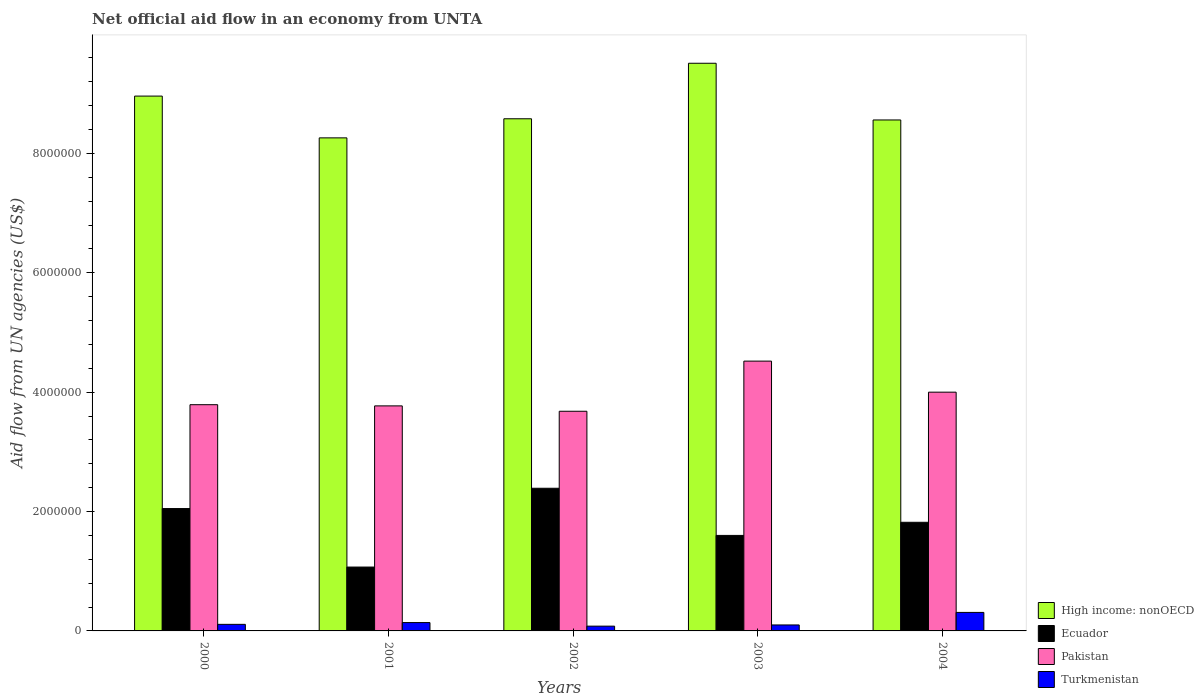How many different coloured bars are there?
Provide a succinct answer. 4. How many groups of bars are there?
Provide a short and direct response. 5. What is the label of the 1st group of bars from the left?
Offer a terse response. 2000. What is the net official aid flow in Turkmenistan in 2001?
Ensure brevity in your answer.  1.40e+05. Across all years, what is the maximum net official aid flow in High income: nonOECD?
Your answer should be compact. 9.51e+06. Across all years, what is the minimum net official aid flow in Pakistan?
Provide a short and direct response. 3.68e+06. In which year was the net official aid flow in Turkmenistan maximum?
Ensure brevity in your answer.  2004. In which year was the net official aid flow in High income: nonOECD minimum?
Give a very brief answer. 2001. What is the total net official aid flow in High income: nonOECD in the graph?
Your response must be concise. 4.39e+07. What is the difference between the net official aid flow in Ecuador in 2001 and that in 2002?
Make the answer very short. -1.32e+06. What is the difference between the net official aid flow in Turkmenistan in 2003 and the net official aid flow in Ecuador in 2001?
Make the answer very short. -9.70e+05. What is the average net official aid flow in Ecuador per year?
Ensure brevity in your answer.  1.79e+06. In the year 2002, what is the difference between the net official aid flow in High income: nonOECD and net official aid flow in Pakistan?
Keep it short and to the point. 4.90e+06. What is the ratio of the net official aid flow in Ecuador in 2003 to that in 2004?
Give a very brief answer. 0.88. Is the difference between the net official aid flow in High income: nonOECD in 2000 and 2001 greater than the difference between the net official aid flow in Pakistan in 2000 and 2001?
Give a very brief answer. Yes. In how many years, is the net official aid flow in High income: nonOECD greater than the average net official aid flow in High income: nonOECD taken over all years?
Your answer should be very brief. 2. Is the sum of the net official aid flow in Turkmenistan in 2001 and 2002 greater than the maximum net official aid flow in Ecuador across all years?
Provide a short and direct response. No. What does the 4th bar from the left in 2002 represents?
Ensure brevity in your answer.  Turkmenistan. Is it the case that in every year, the sum of the net official aid flow in Pakistan and net official aid flow in Ecuador is greater than the net official aid flow in High income: nonOECD?
Make the answer very short. No. How many years are there in the graph?
Ensure brevity in your answer.  5. Does the graph contain any zero values?
Your answer should be very brief. No. Where does the legend appear in the graph?
Your answer should be compact. Bottom right. How many legend labels are there?
Your response must be concise. 4. How are the legend labels stacked?
Offer a terse response. Vertical. What is the title of the graph?
Provide a succinct answer. Net official aid flow in an economy from UNTA. What is the label or title of the X-axis?
Provide a short and direct response. Years. What is the label or title of the Y-axis?
Your answer should be very brief. Aid flow from UN agencies (US$). What is the Aid flow from UN agencies (US$) in High income: nonOECD in 2000?
Keep it short and to the point. 8.96e+06. What is the Aid flow from UN agencies (US$) in Ecuador in 2000?
Your answer should be compact. 2.05e+06. What is the Aid flow from UN agencies (US$) in Pakistan in 2000?
Offer a terse response. 3.79e+06. What is the Aid flow from UN agencies (US$) in High income: nonOECD in 2001?
Ensure brevity in your answer.  8.26e+06. What is the Aid flow from UN agencies (US$) of Ecuador in 2001?
Ensure brevity in your answer.  1.07e+06. What is the Aid flow from UN agencies (US$) in Pakistan in 2001?
Make the answer very short. 3.77e+06. What is the Aid flow from UN agencies (US$) of High income: nonOECD in 2002?
Offer a terse response. 8.58e+06. What is the Aid flow from UN agencies (US$) of Ecuador in 2002?
Offer a terse response. 2.39e+06. What is the Aid flow from UN agencies (US$) in Pakistan in 2002?
Provide a succinct answer. 3.68e+06. What is the Aid flow from UN agencies (US$) of High income: nonOECD in 2003?
Provide a succinct answer. 9.51e+06. What is the Aid flow from UN agencies (US$) of Ecuador in 2003?
Your answer should be compact. 1.60e+06. What is the Aid flow from UN agencies (US$) in Pakistan in 2003?
Offer a terse response. 4.52e+06. What is the Aid flow from UN agencies (US$) in High income: nonOECD in 2004?
Your answer should be compact. 8.56e+06. What is the Aid flow from UN agencies (US$) in Ecuador in 2004?
Ensure brevity in your answer.  1.82e+06. What is the Aid flow from UN agencies (US$) in Pakistan in 2004?
Ensure brevity in your answer.  4.00e+06. Across all years, what is the maximum Aid flow from UN agencies (US$) of High income: nonOECD?
Give a very brief answer. 9.51e+06. Across all years, what is the maximum Aid flow from UN agencies (US$) in Ecuador?
Provide a succinct answer. 2.39e+06. Across all years, what is the maximum Aid flow from UN agencies (US$) of Pakistan?
Make the answer very short. 4.52e+06. Across all years, what is the maximum Aid flow from UN agencies (US$) in Turkmenistan?
Keep it short and to the point. 3.10e+05. Across all years, what is the minimum Aid flow from UN agencies (US$) of High income: nonOECD?
Offer a terse response. 8.26e+06. Across all years, what is the minimum Aid flow from UN agencies (US$) in Ecuador?
Offer a very short reply. 1.07e+06. Across all years, what is the minimum Aid flow from UN agencies (US$) in Pakistan?
Ensure brevity in your answer.  3.68e+06. What is the total Aid flow from UN agencies (US$) in High income: nonOECD in the graph?
Offer a very short reply. 4.39e+07. What is the total Aid flow from UN agencies (US$) in Ecuador in the graph?
Give a very brief answer. 8.93e+06. What is the total Aid flow from UN agencies (US$) in Pakistan in the graph?
Make the answer very short. 1.98e+07. What is the total Aid flow from UN agencies (US$) in Turkmenistan in the graph?
Your response must be concise. 7.40e+05. What is the difference between the Aid flow from UN agencies (US$) in High income: nonOECD in 2000 and that in 2001?
Give a very brief answer. 7.00e+05. What is the difference between the Aid flow from UN agencies (US$) of Ecuador in 2000 and that in 2001?
Offer a terse response. 9.80e+05. What is the difference between the Aid flow from UN agencies (US$) of Pakistan in 2000 and that in 2001?
Your answer should be compact. 2.00e+04. What is the difference between the Aid flow from UN agencies (US$) of Turkmenistan in 2000 and that in 2001?
Provide a succinct answer. -3.00e+04. What is the difference between the Aid flow from UN agencies (US$) of Pakistan in 2000 and that in 2002?
Provide a succinct answer. 1.10e+05. What is the difference between the Aid flow from UN agencies (US$) of Turkmenistan in 2000 and that in 2002?
Provide a succinct answer. 3.00e+04. What is the difference between the Aid flow from UN agencies (US$) of High income: nonOECD in 2000 and that in 2003?
Give a very brief answer. -5.50e+05. What is the difference between the Aid flow from UN agencies (US$) of Ecuador in 2000 and that in 2003?
Give a very brief answer. 4.50e+05. What is the difference between the Aid flow from UN agencies (US$) of Pakistan in 2000 and that in 2003?
Keep it short and to the point. -7.30e+05. What is the difference between the Aid flow from UN agencies (US$) in High income: nonOECD in 2000 and that in 2004?
Provide a short and direct response. 4.00e+05. What is the difference between the Aid flow from UN agencies (US$) in Ecuador in 2000 and that in 2004?
Provide a short and direct response. 2.30e+05. What is the difference between the Aid flow from UN agencies (US$) in Pakistan in 2000 and that in 2004?
Offer a terse response. -2.10e+05. What is the difference between the Aid flow from UN agencies (US$) in Turkmenistan in 2000 and that in 2004?
Provide a short and direct response. -2.00e+05. What is the difference between the Aid flow from UN agencies (US$) in High income: nonOECD in 2001 and that in 2002?
Make the answer very short. -3.20e+05. What is the difference between the Aid flow from UN agencies (US$) of Ecuador in 2001 and that in 2002?
Provide a short and direct response. -1.32e+06. What is the difference between the Aid flow from UN agencies (US$) in High income: nonOECD in 2001 and that in 2003?
Provide a short and direct response. -1.25e+06. What is the difference between the Aid flow from UN agencies (US$) of Ecuador in 2001 and that in 2003?
Keep it short and to the point. -5.30e+05. What is the difference between the Aid flow from UN agencies (US$) in Pakistan in 2001 and that in 2003?
Ensure brevity in your answer.  -7.50e+05. What is the difference between the Aid flow from UN agencies (US$) of High income: nonOECD in 2001 and that in 2004?
Your response must be concise. -3.00e+05. What is the difference between the Aid flow from UN agencies (US$) of Ecuador in 2001 and that in 2004?
Make the answer very short. -7.50e+05. What is the difference between the Aid flow from UN agencies (US$) of Pakistan in 2001 and that in 2004?
Give a very brief answer. -2.30e+05. What is the difference between the Aid flow from UN agencies (US$) of High income: nonOECD in 2002 and that in 2003?
Ensure brevity in your answer.  -9.30e+05. What is the difference between the Aid flow from UN agencies (US$) in Ecuador in 2002 and that in 2003?
Give a very brief answer. 7.90e+05. What is the difference between the Aid flow from UN agencies (US$) in Pakistan in 2002 and that in 2003?
Your answer should be very brief. -8.40e+05. What is the difference between the Aid flow from UN agencies (US$) of High income: nonOECD in 2002 and that in 2004?
Provide a succinct answer. 2.00e+04. What is the difference between the Aid flow from UN agencies (US$) in Ecuador in 2002 and that in 2004?
Make the answer very short. 5.70e+05. What is the difference between the Aid flow from UN agencies (US$) of Pakistan in 2002 and that in 2004?
Keep it short and to the point. -3.20e+05. What is the difference between the Aid flow from UN agencies (US$) in High income: nonOECD in 2003 and that in 2004?
Ensure brevity in your answer.  9.50e+05. What is the difference between the Aid flow from UN agencies (US$) of Pakistan in 2003 and that in 2004?
Offer a very short reply. 5.20e+05. What is the difference between the Aid flow from UN agencies (US$) of Turkmenistan in 2003 and that in 2004?
Your answer should be very brief. -2.10e+05. What is the difference between the Aid flow from UN agencies (US$) of High income: nonOECD in 2000 and the Aid flow from UN agencies (US$) of Ecuador in 2001?
Give a very brief answer. 7.89e+06. What is the difference between the Aid flow from UN agencies (US$) in High income: nonOECD in 2000 and the Aid flow from UN agencies (US$) in Pakistan in 2001?
Provide a short and direct response. 5.19e+06. What is the difference between the Aid flow from UN agencies (US$) of High income: nonOECD in 2000 and the Aid flow from UN agencies (US$) of Turkmenistan in 2001?
Your answer should be very brief. 8.82e+06. What is the difference between the Aid flow from UN agencies (US$) of Ecuador in 2000 and the Aid flow from UN agencies (US$) of Pakistan in 2001?
Your response must be concise. -1.72e+06. What is the difference between the Aid flow from UN agencies (US$) in Ecuador in 2000 and the Aid flow from UN agencies (US$) in Turkmenistan in 2001?
Your response must be concise. 1.91e+06. What is the difference between the Aid flow from UN agencies (US$) of Pakistan in 2000 and the Aid flow from UN agencies (US$) of Turkmenistan in 2001?
Offer a terse response. 3.65e+06. What is the difference between the Aid flow from UN agencies (US$) in High income: nonOECD in 2000 and the Aid flow from UN agencies (US$) in Ecuador in 2002?
Keep it short and to the point. 6.57e+06. What is the difference between the Aid flow from UN agencies (US$) of High income: nonOECD in 2000 and the Aid flow from UN agencies (US$) of Pakistan in 2002?
Offer a very short reply. 5.28e+06. What is the difference between the Aid flow from UN agencies (US$) of High income: nonOECD in 2000 and the Aid flow from UN agencies (US$) of Turkmenistan in 2002?
Give a very brief answer. 8.88e+06. What is the difference between the Aid flow from UN agencies (US$) of Ecuador in 2000 and the Aid flow from UN agencies (US$) of Pakistan in 2002?
Offer a terse response. -1.63e+06. What is the difference between the Aid flow from UN agencies (US$) in Ecuador in 2000 and the Aid flow from UN agencies (US$) in Turkmenistan in 2002?
Your response must be concise. 1.97e+06. What is the difference between the Aid flow from UN agencies (US$) in Pakistan in 2000 and the Aid flow from UN agencies (US$) in Turkmenistan in 2002?
Keep it short and to the point. 3.71e+06. What is the difference between the Aid flow from UN agencies (US$) of High income: nonOECD in 2000 and the Aid flow from UN agencies (US$) of Ecuador in 2003?
Provide a succinct answer. 7.36e+06. What is the difference between the Aid flow from UN agencies (US$) in High income: nonOECD in 2000 and the Aid flow from UN agencies (US$) in Pakistan in 2003?
Your response must be concise. 4.44e+06. What is the difference between the Aid flow from UN agencies (US$) in High income: nonOECD in 2000 and the Aid flow from UN agencies (US$) in Turkmenistan in 2003?
Ensure brevity in your answer.  8.86e+06. What is the difference between the Aid flow from UN agencies (US$) in Ecuador in 2000 and the Aid flow from UN agencies (US$) in Pakistan in 2003?
Provide a succinct answer. -2.47e+06. What is the difference between the Aid flow from UN agencies (US$) in Ecuador in 2000 and the Aid flow from UN agencies (US$) in Turkmenistan in 2003?
Make the answer very short. 1.95e+06. What is the difference between the Aid flow from UN agencies (US$) of Pakistan in 2000 and the Aid flow from UN agencies (US$) of Turkmenistan in 2003?
Offer a terse response. 3.69e+06. What is the difference between the Aid flow from UN agencies (US$) of High income: nonOECD in 2000 and the Aid flow from UN agencies (US$) of Ecuador in 2004?
Give a very brief answer. 7.14e+06. What is the difference between the Aid flow from UN agencies (US$) of High income: nonOECD in 2000 and the Aid flow from UN agencies (US$) of Pakistan in 2004?
Keep it short and to the point. 4.96e+06. What is the difference between the Aid flow from UN agencies (US$) of High income: nonOECD in 2000 and the Aid flow from UN agencies (US$) of Turkmenistan in 2004?
Ensure brevity in your answer.  8.65e+06. What is the difference between the Aid flow from UN agencies (US$) of Ecuador in 2000 and the Aid flow from UN agencies (US$) of Pakistan in 2004?
Provide a short and direct response. -1.95e+06. What is the difference between the Aid flow from UN agencies (US$) in Ecuador in 2000 and the Aid flow from UN agencies (US$) in Turkmenistan in 2004?
Provide a succinct answer. 1.74e+06. What is the difference between the Aid flow from UN agencies (US$) in Pakistan in 2000 and the Aid flow from UN agencies (US$) in Turkmenistan in 2004?
Offer a terse response. 3.48e+06. What is the difference between the Aid flow from UN agencies (US$) of High income: nonOECD in 2001 and the Aid flow from UN agencies (US$) of Ecuador in 2002?
Provide a succinct answer. 5.87e+06. What is the difference between the Aid flow from UN agencies (US$) of High income: nonOECD in 2001 and the Aid flow from UN agencies (US$) of Pakistan in 2002?
Make the answer very short. 4.58e+06. What is the difference between the Aid flow from UN agencies (US$) in High income: nonOECD in 2001 and the Aid flow from UN agencies (US$) in Turkmenistan in 2002?
Offer a terse response. 8.18e+06. What is the difference between the Aid flow from UN agencies (US$) in Ecuador in 2001 and the Aid flow from UN agencies (US$) in Pakistan in 2002?
Offer a very short reply. -2.61e+06. What is the difference between the Aid flow from UN agencies (US$) of Ecuador in 2001 and the Aid flow from UN agencies (US$) of Turkmenistan in 2002?
Provide a succinct answer. 9.90e+05. What is the difference between the Aid flow from UN agencies (US$) of Pakistan in 2001 and the Aid flow from UN agencies (US$) of Turkmenistan in 2002?
Provide a short and direct response. 3.69e+06. What is the difference between the Aid flow from UN agencies (US$) in High income: nonOECD in 2001 and the Aid flow from UN agencies (US$) in Ecuador in 2003?
Your answer should be very brief. 6.66e+06. What is the difference between the Aid flow from UN agencies (US$) of High income: nonOECD in 2001 and the Aid flow from UN agencies (US$) of Pakistan in 2003?
Your answer should be compact. 3.74e+06. What is the difference between the Aid flow from UN agencies (US$) in High income: nonOECD in 2001 and the Aid flow from UN agencies (US$) in Turkmenistan in 2003?
Make the answer very short. 8.16e+06. What is the difference between the Aid flow from UN agencies (US$) of Ecuador in 2001 and the Aid flow from UN agencies (US$) of Pakistan in 2003?
Offer a very short reply. -3.45e+06. What is the difference between the Aid flow from UN agencies (US$) of Ecuador in 2001 and the Aid flow from UN agencies (US$) of Turkmenistan in 2003?
Your answer should be compact. 9.70e+05. What is the difference between the Aid flow from UN agencies (US$) of Pakistan in 2001 and the Aid flow from UN agencies (US$) of Turkmenistan in 2003?
Ensure brevity in your answer.  3.67e+06. What is the difference between the Aid flow from UN agencies (US$) of High income: nonOECD in 2001 and the Aid flow from UN agencies (US$) of Ecuador in 2004?
Your answer should be very brief. 6.44e+06. What is the difference between the Aid flow from UN agencies (US$) in High income: nonOECD in 2001 and the Aid flow from UN agencies (US$) in Pakistan in 2004?
Offer a terse response. 4.26e+06. What is the difference between the Aid flow from UN agencies (US$) of High income: nonOECD in 2001 and the Aid flow from UN agencies (US$) of Turkmenistan in 2004?
Offer a terse response. 7.95e+06. What is the difference between the Aid flow from UN agencies (US$) of Ecuador in 2001 and the Aid flow from UN agencies (US$) of Pakistan in 2004?
Your response must be concise. -2.93e+06. What is the difference between the Aid flow from UN agencies (US$) of Ecuador in 2001 and the Aid flow from UN agencies (US$) of Turkmenistan in 2004?
Provide a succinct answer. 7.60e+05. What is the difference between the Aid flow from UN agencies (US$) in Pakistan in 2001 and the Aid flow from UN agencies (US$) in Turkmenistan in 2004?
Ensure brevity in your answer.  3.46e+06. What is the difference between the Aid flow from UN agencies (US$) in High income: nonOECD in 2002 and the Aid flow from UN agencies (US$) in Ecuador in 2003?
Offer a terse response. 6.98e+06. What is the difference between the Aid flow from UN agencies (US$) in High income: nonOECD in 2002 and the Aid flow from UN agencies (US$) in Pakistan in 2003?
Keep it short and to the point. 4.06e+06. What is the difference between the Aid flow from UN agencies (US$) in High income: nonOECD in 2002 and the Aid flow from UN agencies (US$) in Turkmenistan in 2003?
Offer a terse response. 8.48e+06. What is the difference between the Aid flow from UN agencies (US$) in Ecuador in 2002 and the Aid flow from UN agencies (US$) in Pakistan in 2003?
Your answer should be very brief. -2.13e+06. What is the difference between the Aid flow from UN agencies (US$) of Ecuador in 2002 and the Aid flow from UN agencies (US$) of Turkmenistan in 2003?
Keep it short and to the point. 2.29e+06. What is the difference between the Aid flow from UN agencies (US$) in Pakistan in 2002 and the Aid flow from UN agencies (US$) in Turkmenistan in 2003?
Ensure brevity in your answer.  3.58e+06. What is the difference between the Aid flow from UN agencies (US$) in High income: nonOECD in 2002 and the Aid flow from UN agencies (US$) in Ecuador in 2004?
Ensure brevity in your answer.  6.76e+06. What is the difference between the Aid flow from UN agencies (US$) in High income: nonOECD in 2002 and the Aid flow from UN agencies (US$) in Pakistan in 2004?
Provide a short and direct response. 4.58e+06. What is the difference between the Aid flow from UN agencies (US$) in High income: nonOECD in 2002 and the Aid flow from UN agencies (US$) in Turkmenistan in 2004?
Give a very brief answer. 8.27e+06. What is the difference between the Aid flow from UN agencies (US$) of Ecuador in 2002 and the Aid flow from UN agencies (US$) of Pakistan in 2004?
Your answer should be compact. -1.61e+06. What is the difference between the Aid flow from UN agencies (US$) of Ecuador in 2002 and the Aid flow from UN agencies (US$) of Turkmenistan in 2004?
Give a very brief answer. 2.08e+06. What is the difference between the Aid flow from UN agencies (US$) of Pakistan in 2002 and the Aid flow from UN agencies (US$) of Turkmenistan in 2004?
Offer a terse response. 3.37e+06. What is the difference between the Aid flow from UN agencies (US$) of High income: nonOECD in 2003 and the Aid flow from UN agencies (US$) of Ecuador in 2004?
Offer a very short reply. 7.69e+06. What is the difference between the Aid flow from UN agencies (US$) of High income: nonOECD in 2003 and the Aid flow from UN agencies (US$) of Pakistan in 2004?
Ensure brevity in your answer.  5.51e+06. What is the difference between the Aid flow from UN agencies (US$) of High income: nonOECD in 2003 and the Aid flow from UN agencies (US$) of Turkmenistan in 2004?
Make the answer very short. 9.20e+06. What is the difference between the Aid flow from UN agencies (US$) in Ecuador in 2003 and the Aid flow from UN agencies (US$) in Pakistan in 2004?
Make the answer very short. -2.40e+06. What is the difference between the Aid flow from UN agencies (US$) of Ecuador in 2003 and the Aid flow from UN agencies (US$) of Turkmenistan in 2004?
Your answer should be very brief. 1.29e+06. What is the difference between the Aid flow from UN agencies (US$) in Pakistan in 2003 and the Aid flow from UN agencies (US$) in Turkmenistan in 2004?
Make the answer very short. 4.21e+06. What is the average Aid flow from UN agencies (US$) of High income: nonOECD per year?
Give a very brief answer. 8.77e+06. What is the average Aid flow from UN agencies (US$) in Ecuador per year?
Your answer should be very brief. 1.79e+06. What is the average Aid flow from UN agencies (US$) in Pakistan per year?
Make the answer very short. 3.95e+06. What is the average Aid flow from UN agencies (US$) of Turkmenistan per year?
Offer a very short reply. 1.48e+05. In the year 2000, what is the difference between the Aid flow from UN agencies (US$) in High income: nonOECD and Aid flow from UN agencies (US$) in Ecuador?
Keep it short and to the point. 6.91e+06. In the year 2000, what is the difference between the Aid flow from UN agencies (US$) of High income: nonOECD and Aid flow from UN agencies (US$) of Pakistan?
Your answer should be very brief. 5.17e+06. In the year 2000, what is the difference between the Aid flow from UN agencies (US$) in High income: nonOECD and Aid flow from UN agencies (US$) in Turkmenistan?
Offer a very short reply. 8.85e+06. In the year 2000, what is the difference between the Aid flow from UN agencies (US$) in Ecuador and Aid flow from UN agencies (US$) in Pakistan?
Give a very brief answer. -1.74e+06. In the year 2000, what is the difference between the Aid flow from UN agencies (US$) of Ecuador and Aid flow from UN agencies (US$) of Turkmenistan?
Offer a very short reply. 1.94e+06. In the year 2000, what is the difference between the Aid flow from UN agencies (US$) of Pakistan and Aid flow from UN agencies (US$) of Turkmenistan?
Provide a succinct answer. 3.68e+06. In the year 2001, what is the difference between the Aid flow from UN agencies (US$) in High income: nonOECD and Aid flow from UN agencies (US$) in Ecuador?
Ensure brevity in your answer.  7.19e+06. In the year 2001, what is the difference between the Aid flow from UN agencies (US$) in High income: nonOECD and Aid flow from UN agencies (US$) in Pakistan?
Offer a terse response. 4.49e+06. In the year 2001, what is the difference between the Aid flow from UN agencies (US$) in High income: nonOECD and Aid flow from UN agencies (US$) in Turkmenistan?
Make the answer very short. 8.12e+06. In the year 2001, what is the difference between the Aid flow from UN agencies (US$) of Ecuador and Aid flow from UN agencies (US$) of Pakistan?
Provide a short and direct response. -2.70e+06. In the year 2001, what is the difference between the Aid flow from UN agencies (US$) of Ecuador and Aid flow from UN agencies (US$) of Turkmenistan?
Your response must be concise. 9.30e+05. In the year 2001, what is the difference between the Aid flow from UN agencies (US$) in Pakistan and Aid flow from UN agencies (US$) in Turkmenistan?
Your response must be concise. 3.63e+06. In the year 2002, what is the difference between the Aid flow from UN agencies (US$) in High income: nonOECD and Aid flow from UN agencies (US$) in Ecuador?
Keep it short and to the point. 6.19e+06. In the year 2002, what is the difference between the Aid flow from UN agencies (US$) of High income: nonOECD and Aid flow from UN agencies (US$) of Pakistan?
Keep it short and to the point. 4.90e+06. In the year 2002, what is the difference between the Aid flow from UN agencies (US$) in High income: nonOECD and Aid flow from UN agencies (US$) in Turkmenistan?
Make the answer very short. 8.50e+06. In the year 2002, what is the difference between the Aid flow from UN agencies (US$) of Ecuador and Aid flow from UN agencies (US$) of Pakistan?
Your answer should be very brief. -1.29e+06. In the year 2002, what is the difference between the Aid flow from UN agencies (US$) in Ecuador and Aid flow from UN agencies (US$) in Turkmenistan?
Provide a succinct answer. 2.31e+06. In the year 2002, what is the difference between the Aid flow from UN agencies (US$) in Pakistan and Aid flow from UN agencies (US$) in Turkmenistan?
Your answer should be very brief. 3.60e+06. In the year 2003, what is the difference between the Aid flow from UN agencies (US$) of High income: nonOECD and Aid flow from UN agencies (US$) of Ecuador?
Your answer should be very brief. 7.91e+06. In the year 2003, what is the difference between the Aid flow from UN agencies (US$) of High income: nonOECD and Aid flow from UN agencies (US$) of Pakistan?
Your answer should be very brief. 4.99e+06. In the year 2003, what is the difference between the Aid flow from UN agencies (US$) in High income: nonOECD and Aid flow from UN agencies (US$) in Turkmenistan?
Your answer should be very brief. 9.41e+06. In the year 2003, what is the difference between the Aid flow from UN agencies (US$) of Ecuador and Aid flow from UN agencies (US$) of Pakistan?
Give a very brief answer. -2.92e+06. In the year 2003, what is the difference between the Aid flow from UN agencies (US$) in Ecuador and Aid flow from UN agencies (US$) in Turkmenistan?
Offer a very short reply. 1.50e+06. In the year 2003, what is the difference between the Aid flow from UN agencies (US$) of Pakistan and Aid flow from UN agencies (US$) of Turkmenistan?
Your answer should be very brief. 4.42e+06. In the year 2004, what is the difference between the Aid flow from UN agencies (US$) in High income: nonOECD and Aid flow from UN agencies (US$) in Ecuador?
Offer a very short reply. 6.74e+06. In the year 2004, what is the difference between the Aid flow from UN agencies (US$) of High income: nonOECD and Aid flow from UN agencies (US$) of Pakistan?
Ensure brevity in your answer.  4.56e+06. In the year 2004, what is the difference between the Aid flow from UN agencies (US$) of High income: nonOECD and Aid flow from UN agencies (US$) of Turkmenistan?
Provide a succinct answer. 8.25e+06. In the year 2004, what is the difference between the Aid flow from UN agencies (US$) of Ecuador and Aid flow from UN agencies (US$) of Pakistan?
Ensure brevity in your answer.  -2.18e+06. In the year 2004, what is the difference between the Aid flow from UN agencies (US$) in Ecuador and Aid flow from UN agencies (US$) in Turkmenistan?
Your answer should be compact. 1.51e+06. In the year 2004, what is the difference between the Aid flow from UN agencies (US$) in Pakistan and Aid flow from UN agencies (US$) in Turkmenistan?
Your response must be concise. 3.69e+06. What is the ratio of the Aid flow from UN agencies (US$) of High income: nonOECD in 2000 to that in 2001?
Offer a terse response. 1.08. What is the ratio of the Aid flow from UN agencies (US$) in Ecuador in 2000 to that in 2001?
Offer a terse response. 1.92. What is the ratio of the Aid flow from UN agencies (US$) in Turkmenistan in 2000 to that in 2001?
Your answer should be compact. 0.79. What is the ratio of the Aid flow from UN agencies (US$) of High income: nonOECD in 2000 to that in 2002?
Keep it short and to the point. 1.04. What is the ratio of the Aid flow from UN agencies (US$) of Ecuador in 2000 to that in 2002?
Make the answer very short. 0.86. What is the ratio of the Aid flow from UN agencies (US$) of Pakistan in 2000 to that in 2002?
Your answer should be very brief. 1.03. What is the ratio of the Aid flow from UN agencies (US$) in Turkmenistan in 2000 to that in 2002?
Make the answer very short. 1.38. What is the ratio of the Aid flow from UN agencies (US$) in High income: nonOECD in 2000 to that in 2003?
Offer a very short reply. 0.94. What is the ratio of the Aid flow from UN agencies (US$) of Ecuador in 2000 to that in 2003?
Give a very brief answer. 1.28. What is the ratio of the Aid flow from UN agencies (US$) in Pakistan in 2000 to that in 2003?
Provide a succinct answer. 0.84. What is the ratio of the Aid flow from UN agencies (US$) in Turkmenistan in 2000 to that in 2003?
Your response must be concise. 1.1. What is the ratio of the Aid flow from UN agencies (US$) in High income: nonOECD in 2000 to that in 2004?
Make the answer very short. 1.05. What is the ratio of the Aid flow from UN agencies (US$) of Ecuador in 2000 to that in 2004?
Offer a very short reply. 1.13. What is the ratio of the Aid flow from UN agencies (US$) of Pakistan in 2000 to that in 2004?
Offer a very short reply. 0.95. What is the ratio of the Aid flow from UN agencies (US$) in Turkmenistan in 2000 to that in 2004?
Your answer should be compact. 0.35. What is the ratio of the Aid flow from UN agencies (US$) in High income: nonOECD in 2001 to that in 2002?
Offer a terse response. 0.96. What is the ratio of the Aid flow from UN agencies (US$) in Ecuador in 2001 to that in 2002?
Keep it short and to the point. 0.45. What is the ratio of the Aid flow from UN agencies (US$) in Pakistan in 2001 to that in 2002?
Provide a short and direct response. 1.02. What is the ratio of the Aid flow from UN agencies (US$) of High income: nonOECD in 2001 to that in 2003?
Offer a terse response. 0.87. What is the ratio of the Aid flow from UN agencies (US$) of Ecuador in 2001 to that in 2003?
Provide a short and direct response. 0.67. What is the ratio of the Aid flow from UN agencies (US$) of Pakistan in 2001 to that in 2003?
Your response must be concise. 0.83. What is the ratio of the Aid flow from UN agencies (US$) in Turkmenistan in 2001 to that in 2003?
Make the answer very short. 1.4. What is the ratio of the Aid flow from UN agencies (US$) in High income: nonOECD in 2001 to that in 2004?
Your answer should be very brief. 0.96. What is the ratio of the Aid flow from UN agencies (US$) in Ecuador in 2001 to that in 2004?
Your response must be concise. 0.59. What is the ratio of the Aid flow from UN agencies (US$) in Pakistan in 2001 to that in 2004?
Offer a very short reply. 0.94. What is the ratio of the Aid flow from UN agencies (US$) in Turkmenistan in 2001 to that in 2004?
Provide a short and direct response. 0.45. What is the ratio of the Aid flow from UN agencies (US$) of High income: nonOECD in 2002 to that in 2003?
Provide a succinct answer. 0.9. What is the ratio of the Aid flow from UN agencies (US$) of Ecuador in 2002 to that in 2003?
Provide a short and direct response. 1.49. What is the ratio of the Aid flow from UN agencies (US$) of Pakistan in 2002 to that in 2003?
Your response must be concise. 0.81. What is the ratio of the Aid flow from UN agencies (US$) in High income: nonOECD in 2002 to that in 2004?
Provide a short and direct response. 1. What is the ratio of the Aid flow from UN agencies (US$) of Ecuador in 2002 to that in 2004?
Provide a succinct answer. 1.31. What is the ratio of the Aid flow from UN agencies (US$) of Pakistan in 2002 to that in 2004?
Give a very brief answer. 0.92. What is the ratio of the Aid flow from UN agencies (US$) of Turkmenistan in 2002 to that in 2004?
Ensure brevity in your answer.  0.26. What is the ratio of the Aid flow from UN agencies (US$) of High income: nonOECD in 2003 to that in 2004?
Offer a very short reply. 1.11. What is the ratio of the Aid flow from UN agencies (US$) in Ecuador in 2003 to that in 2004?
Ensure brevity in your answer.  0.88. What is the ratio of the Aid flow from UN agencies (US$) of Pakistan in 2003 to that in 2004?
Give a very brief answer. 1.13. What is the ratio of the Aid flow from UN agencies (US$) of Turkmenistan in 2003 to that in 2004?
Provide a succinct answer. 0.32. What is the difference between the highest and the second highest Aid flow from UN agencies (US$) of Pakistan?
Your answer should be compact. 5.20e+05. What is the difference between the highest and the second highest Aid flow from UN agencies (US$) of Turkmenistan?
Provide a short and direct response. 1.70e+05. What is the difference between the highest and the lowest Aid flow from UN agencies (US$) in High income: nonOECD?
Your answer should be compact. 1.25e+06. What is the difference between the highest and the lowest Aid flow from UN agencies (US$) of Ecuador?
Keep it short and to the point. 1.32e+06. What is the difference between the highest and the lowest Aid flow from UN agencies (US$) in Pakistan?
Provide a succinct answer. 8.40e+05. 